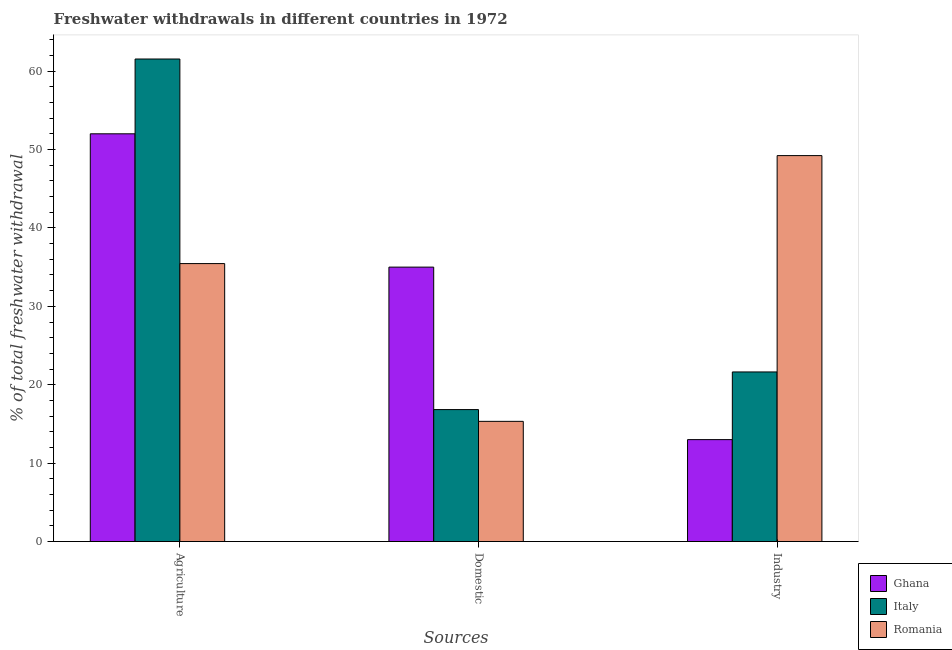Are the number of bars per tick equal to the number of legend labels?
Offer a very short reply. Yes. Are the number of bars on each tick of the X-axis equal?
Give a very brief answer. Yes. How many bars are there on the 3rd tick from the left?
Provide a succinct answer. 3. What is the label of the 3rd group of bars from the left?
Provide a short and direct response. Industry. What is the percentage of freshwater withdrawal for agriculture in Ghana?
Your answer should be very brief. 52. Across all countries, what is the maximum percentage of freshwater withdrawal for agriculture?
Your answer should be compact. 61.54. Across all countries, what is the minimum percentage of freshwater withdrawal for domestic purposes?
Ensure brevity in your answer.  15.33. In which country was the percentage of freshwater withdrawal for agriculture minimum?
Provide a succinct answer. Romania. What is the total percentage of freshwater withdrawal for industry in the graph?
Keep it short and to the point. 83.85. What is the difference between the percentage of freshwater withdrawal for domestic purposes in Romania and that in Italy?
Keep it short and to the point. -1.5. What is the difference between the percentage of freshwater withdrawal for industry in Ghana and the percentage of freshwater withdrawal for agriculture in Romania?
Provide a succinct answer. -22.45. What is the average percentage of freshwater withdrawal for agriculture per country?
Give a very brief answer. 49.66. In how many countries, is the percentage of freshwater withdrawal for industry greater than 6 %?
Give a very brief answer. 3. What is the ratio of the percentage of freshwater withdrawal for industry in Ghana to that in Italy?
Provide a succinct answer. 0.6. Is the percentage of freshwater withdrawal for industry in Ghana less than that in Romania?
Give a very brief answer. Yes. Is the difference between the percentage of freshwater withdrawal for agriculture in Romania and Italy greater than the difference between the percentage of freshwater withdrawal for domestic purposes in Romania and Italy?
Your response must be concise. No. What is the difference between the highest and the second highest percentage of freshwater withdrawal for domestic purposes?
Provide a succinct answer. 18.17. What is the difference between the highest and the lowest percentage of freshwater withdrawal for domestic purposes?
Your answer should be compact. 19.67. In how many countries, is the percentage of freshwater withdrawal for agriculture greater than the average percentage of freshwater withdrawal for agriculture taken over all countries?
Offer a terse response. 2. What does the 2nd bar from the left in Industry represents?
Provide a short and direct response. Italy. Is it the case that in every country, the sum of the percentage of freshwater withdrawal for agriculture and percentage of freshwater withdrawal for domestic purposes is greater than the percentage of freshwater withdrawal for industry?
Provide a short and direct response. Yes. How many bars are there?
Provide a succinct answer. 9. Are the values on the major ticks of Y-axis written in scientific E-notation?
Your response must be concise. No. Does the graph contain grids?
Keep it short and to the point. No. How many legend labels are there?
Make the answer very short. 3. What is the title of the graph?
Provide a short and direct response. Freshwater withdrawals in different countries in 1972. Does "Central African Republic" appear as one of the legend labels in the graph?
Offer a terse response. No. What is the label or title of the X-axis?
Offer a very short reply. Sources. What is the label or title of the Y-axis?
Ensure brevity in your answer.  % of total freshwater withdrawal. What is the % of total freshwater withdrawal of Italy in Agriculture?
Provide a succinct answer. 61.54. What is the % of total freshwater withdrawal in Romania in Agriculture?
Your answer should be very brief. 35.45. What is the % of total freshwater withdrawal in Ghana in Domestic?
Keep it short and to the point. 35. What is the % of total freshwater withdrawal of Italy in Domestic?
Your response must be concise. 16.83. What is the % of total freshwater withdrawal in Romania in Domestic?
Give a very brief answer. 15.33. What is the % of total freshwater withdrawal of Italy in Industry?
Offer a terse response. 21.63. What is the % of total freshwater withdrawal of Romania in Industry?
Offer a very short reply. 49.22. Across all Sources, what is the maximum % of total freshwater withdrawal in Ghana?
Offer a terse response. 52. Across all Sources, what is the maximum % of total freshwater withdrawal in Italy?
Offer a very short reply. 61.54. Across all Sources, what is the maximum % of total freshwater withdrawal of Romania?
Your answer should be compact. 49.22. Across all Sources, what is the minimum % of total freshwater withdrawal of Italy?
Offer a terse response. 16.83. Across all Sources, what is the minimum % of total freshwater withdrawal in Romania?
Provide a succinct answer. 15.33. What is the total % of total freshwater withdrawal in Ghana in the graph?
Provide a short and direct response. 100. What is the difference between the % of total freshwater withdrawal in Italy in Agriculture and that in Domestic?
Make the answer very short. 44.71. What is the difference between the % of total freshwater withdrawal of Romania in Agriculture and that in Domestic?
Ensure brevity in your answer.  20.12. What is the difference between the % of total freshwater withdrawal in Ghana in Agriculture and that in Industry?
Provide a succinct answer. 39. What is the difference between the % of total freshwater withdrawal in Italy in Agriculture and that in Industry?
Your response must be concise. 39.91. What is the difference between the % of total freshwater withdrawal of Romania in Agriculture and that in Industry?
Give a very brief answer. -13.77. What is the difference between the % of total freshwater withdrawal of Ghana in Domestic and that in Industry?
Give a very brief answer. 22. What is the difference between the % of total freshwater withdrawal in Italy in Domestic and that in Industry?
Ensure brevity in your answer.  -4.8. What is the difference between the % of total freshwater withdrawal in Romania in Domestic and that in Industry?
Your response must be concise. -33.89. What is the difference between the % of total freshwater withdrawal in Ghana in Agriculture and the % of total freshwater withdrawal in Italy in Domestic?
Offer a terse response. 35.17. What is the difference between the % of total freshwater withdrawal in Ghana in Agriculture and the % of total freshwater withdrawal in Romania in Domestic?
Offer a terse response. 36.67. What is the difference between the % of total freshwater withdrawal of Italy in Agriculture and the % of total freshwater withdrawal of Romania in Domestic?
Make the answer very short. 46.21. What is the difference between the % of total freshwater withdrawal of Ghana in Agriculture and the % of total freshwater withdrawal of Italy in Industry?
Make the answer very short. 30.37. What is the difference between the % of total freshwater withdrawal in Ghana in Agriculture and the % of total freshwater withdrawal in Romania in Industry?
Keep it short and to the point. 2.78. What is the difference between the % of total freshwater withdrawal in Italy in Agriculture and the % of total freshwater withdrawal in Romania in Industry?
Offer a very short reply. 12.32. What is the difference between the % of total freshwater withdrawal of Ghana in Domestic and the % of total freshwater withdrawal of Italy in Industry?
Provide a succinct answer. 13.37. What is the difference between the % of total freshwater withdrawal in Ghana in Domestic and the % of total freshwater withdrawal in Romania in Industry?
Provide a short and direct response. -14.22. What is the difference between the % of total freshwater withdrawal in Italy in Domestic and the % of total freshwater withdrawal in Romania in Industry?
Make the answer very short. -32.39. What is the average % of total freshwater withdrawal in Ghana per Sources?
Offer a very short reply. 33.33. What is the average % of total freshwater withdrawal of Italy per Sources?
Ensure brevity in your answer.  33.33. What is the average % of total freshwater withdrawal in Romania per Sources?
Your answer should be compact. 33.33. What is the difference between the % of total freshwater withdrawal of Ghana and % of total freshwater withdrawal of Italy in Agriculture?
Offer a terse response. -9.54. What is the difference between the % of total freshwater withdrawal in Ghana and % of total freshwater withdrawal in Romania in Agriculture?
Ensure brevity in your answer.  16.55. What is the difference between the % of total freshwater withdrawal of Italy and % of total freshwater withdrawal of Romania in Agriculture?
Make the answer very short. 26.09. What is the difference between the % of total freshwater withdrawal of Ghana and % of total freshwater withdrawal of Italy in Domestic?
Give a very brief answer. 18.17. What is the difference between the % of total freshwater withdrawal in Ghana and % of total freshwater withdrawal in Romania in Domestic?
Provide a short and direct response. 19.67. What is the difference between the % of total freshwater withdrawal of Ghana and % of total freshwater withdrawal of Italy in Industry?
Ensure brevity in your answer.  -8.63. What is the difference between the % of total freshwater withdrawal of Ghana and % of total freshwater withdrawal of Romania in Industry?
Ensure brevity in your answer.  -36.22. What is the difference between the % of total freshwater withdrawal in Italy and % of total freshwater withdrawal in Romania in Industry?
Keep it short and to the point. -27.59. What is the ratio of the % of total freshwater withdrawal in Ghana in Agriculture to that in Domestic?
Your answer should be very brief. 1.49. What is the ratio of the % of total freshwater withdrawal in Italy in Agriculture to that in Domestic?
Make the answer very short. 3.66. What is the ratio of the % of total freshwater withdrawal in Romania in Agriculture to that in Domestic?
Keep it short and to the point. 2.31. What is the ratio of the % of total freshwater withdrawal of Italy in Agriculture to that in Industry?
Provide a succinct answer. 2.85. What is the ratio of the % of total freshwater withdrawal of Romania in Agriculture to that in Industry?
Your answer should be very brief. 0.72. What is the ratio of the % of total freshwater withdrawal of Ghana in Domestic to that in Industry?
Provide a succinct answer. 2.69. What is the ratio of the % of total freshwater withdrawal in Italy in Domestic to that in Industry?
Your response must be concise. 0.78. What is the ratio of the % of total freshwater withdrawal in Romania in Domestic to that in Industry?
Offer a very short reply. 0.31. What is the difference between the highest and the second highest % of total freshwater withdrawal in Italy?
Offer a very short reply. 39.91. What is the difference between the highest and the second highest % of total freshwater withdrawal of Romania?
Your response must be concise. 13.77. What is the difference between the highest and the lowest % of total freshwater withdrawal of Italy?
Ensure brevity in your answer.  44.71. What is the difference between the highest and the lowest % of total freshwater withdrawal of Romania?
Ensure brevity in your answer.  33.89. 